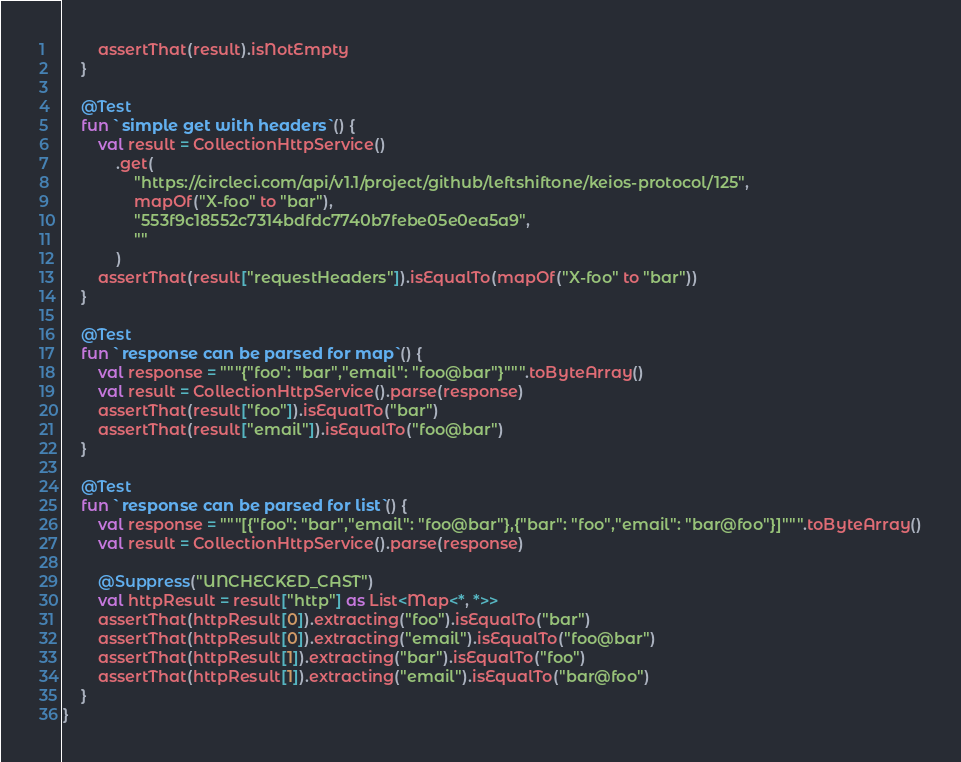Convert code to text. <code><loc_0><loc_0><loc_500><loc_500><_Kotlin_>        assertThat(result).isNotEmpty
    }

    @Test
    fun `simple get with headers`() {
        val result = CollectionHttpService()
            .get(
                "https://circleci.com/api/v1.1/project/github/leftshiftone/keios-protocol/125",
                mapOf("X-foo" to "bar"),
                "553f9c18552c7314bdfdc7740b7febe05e0ea5a9",
                ""
            )
        assertThat(result["requestHeaders"]).isEqualTo(mapOf("X-foo" to "bar"))
    }

    @Test
    fun `response can be parsed for map`() {
        val response = """{"foo": "bar","email": "foo@bar"}""".toByteArray()
        val result = CollectionHttpService().parse(response)
        assertThat(result["foo"]).isEqualTo("bar")
        assertThat(result["email"]).isEqualTo("foo@bar")
    }

    @Test
    fun `response can be parsed for list`() {
        val response = """[{"foo": "bar","email": "foo@bar"},{"bar": "foo","email": "bar@foo"}]""".toByteArray()
        val result = CollectionHttpService().parse(response)

        @Suppress("UNCHECKED_CAST")
        val httpResult = result["http"] as List<Map<*, *>>
        assertThat(httpResult[0]).extracting("foo").isEqualTo("bar")
        assertThat(httpResult[0]).extracting("email").isEqualTo("foo@bar")
        assertThat(httpResult[1]).extracting("bar").isEqualTo("foo")
        assertThat(httpResult[1]).extracting("email").isEqualTo("bar@foo")
    }
}</code> 